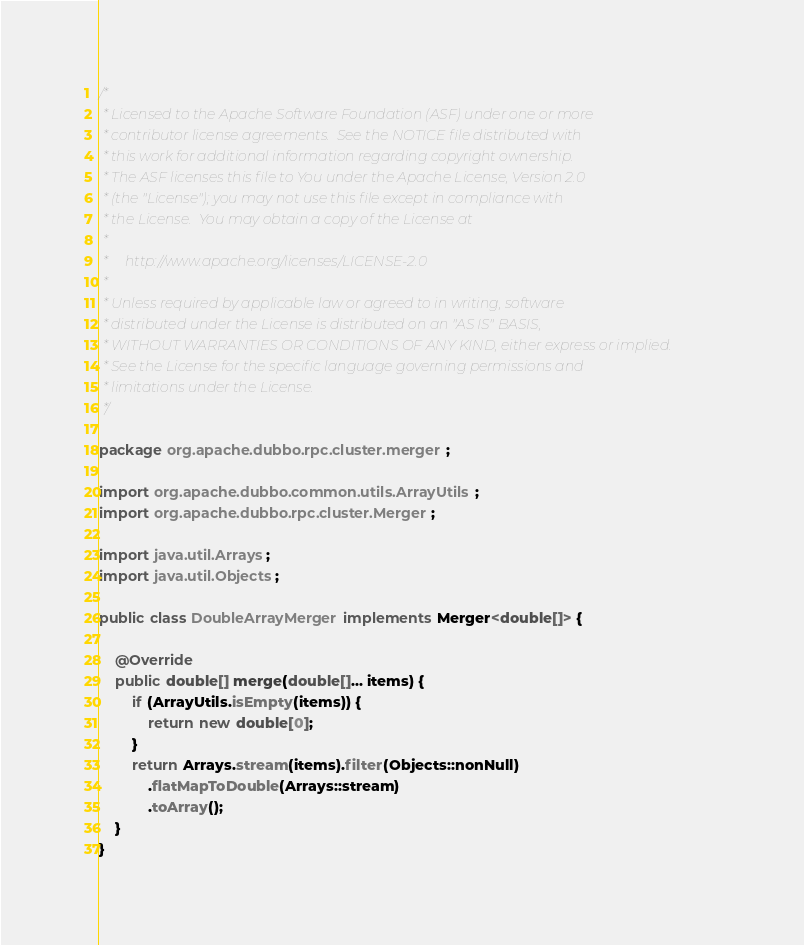Convert code to text. <code><loc_0><loc_0><loc_500><loc_500><_Java_>/*
 * Licensed to the Apache Software Foundation (ASF) under one or more
 * contributor license agreements.  See the NOTICE file distributed with
 * this work for additional information regarding copyright ownership.
 * The ASF licenses this file to You under the Apache License, Version 2.0
 * (the "License"); you may not use this file except in compliance with
 * the License.  You may obtain a copy of the License at
 *
 *     http://www.apache.org/licenses/LICENSE-2.0
 *
 * Unless required by applicable law or agreed to in writing, software
 * distributed under the License is distributed on an "AS IS" BASIS,
 * WITHOUT WARRANTIES OR CONDITIONS OF ANY KIND, either express or implied.
 * See the License for the specific language governing permissions and
 * limitations under the License.
 */

package org.apache.dubbo.rpc.cluster.merger;

import org.apache.dubbo.common.utils.ArrayUtils;
import org.apache.dubbo.rpc.cluster.Merger;

import java.util.Arrays;
import java.util.Objects;

public class DoubleArrayMerger implements Merger<double[]> {

    @Override
    public double[] merge(double[]... items) {
        if (ArrayUtils.isEmpty(items)) {
            return new double[0];
        }
        return Arrays.stream(items).filter(Objects::nonNull)
            .flatMapToDouble(Arrays::stream)
            .toArray();
    }
}
</code> 